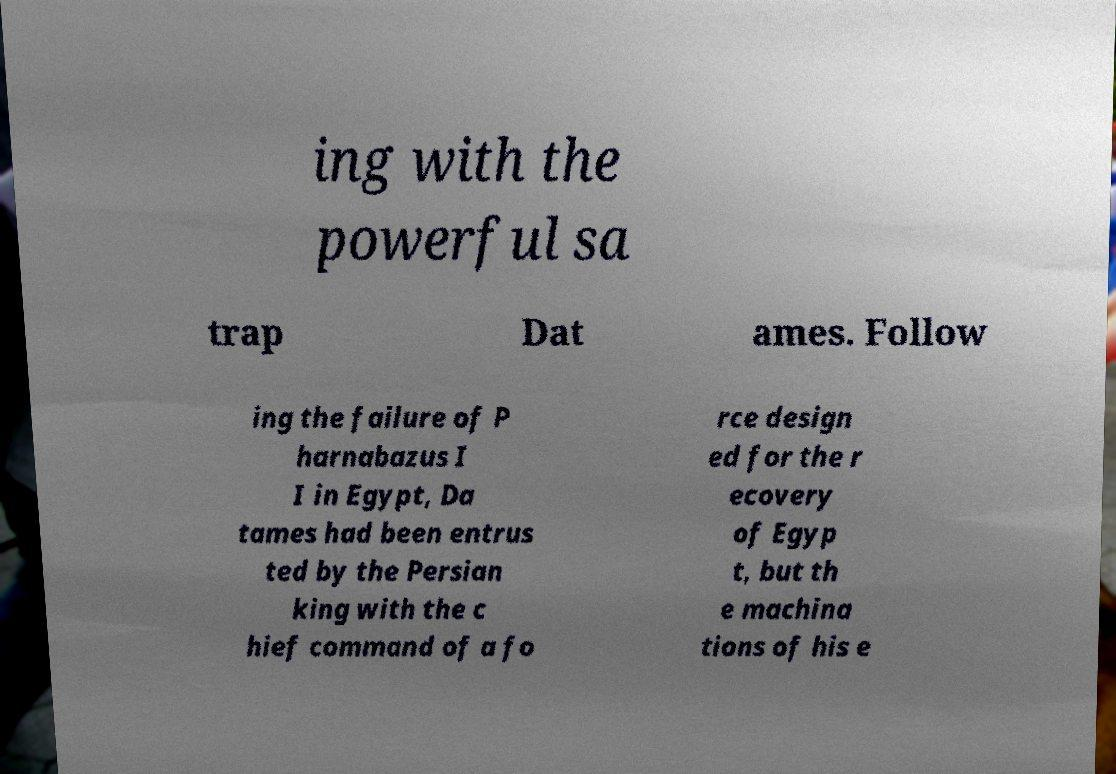Please identify and transcribe the text found in this image. ing with the powerful sa trap Dat ames. Follow ing the failure of P harnabazus I I in Egypt, Da tames had been entrus ted by the Persian king with the c hief command of a fo rce design ed for the r ecovery of Egyp t, but th e machina tions of his e 